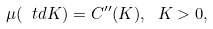<formula> <loc_0><loc_0><loc_500><loc_500>\mu ( \ t d K ) = C ^ { \prime \prime } ( K ) , \ K > 0 ,</formula> 